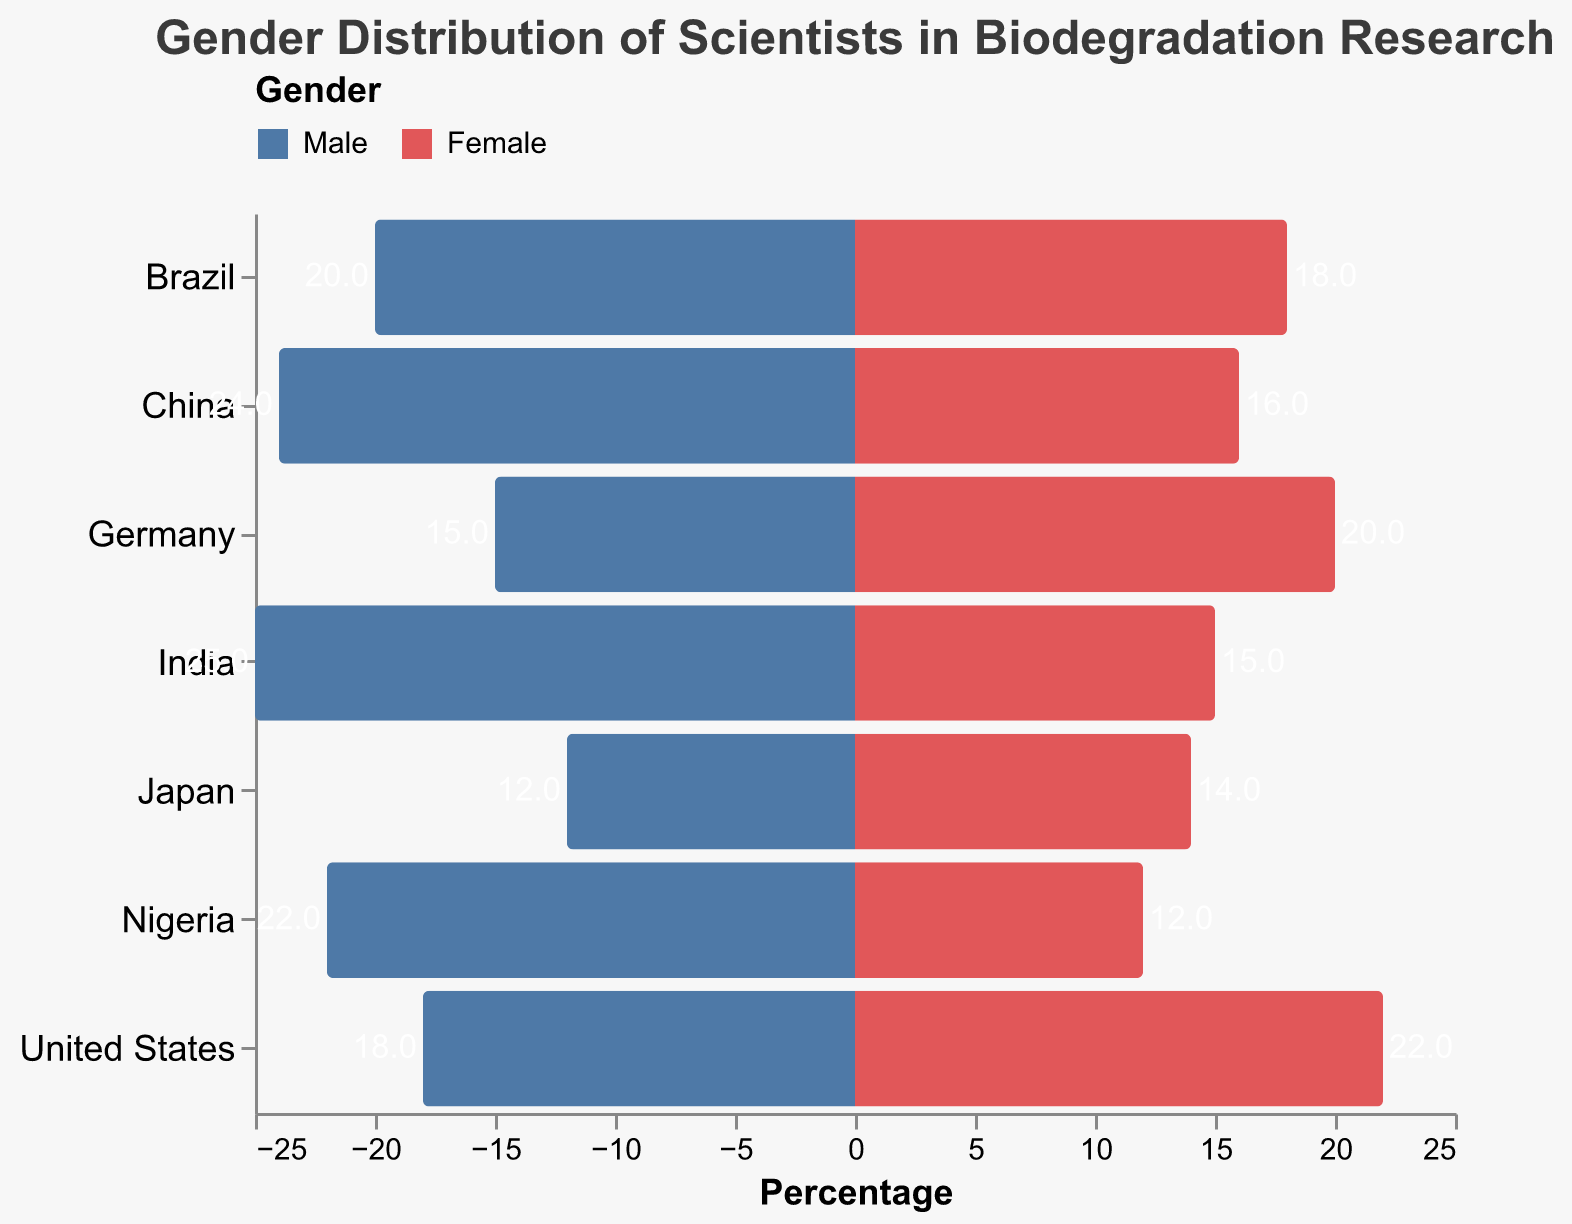What is the title of the figure? The title is displayed at the top of the figure and often summarizes the main topic.
Answer: Gender Distribution of Scientists in Biodegradation Research What is the percentage of female scientists in Germany? Locate Germany on the y-axis, and then check the bar corresponding to the female scientists (marked in red). The tooltip shows 20%.
Answer: 20% How many countries are represented in the pyramid plot? Count the distinct country labels listed on the y-axis.
Answer: 6 Which developed country has the highest percentage of female scientists? Compare the lengths of the red bars for developed countries (United States, Germany, Japan). The United States has the longest bar at 22%.
Answer: United States Which developing country has more male scientists, India or China? Compare the lengths of the blue bars for India and China. India has a 25% bar, while China has a 24% bar.
Answer: India What is the combined percentage of male scientists in Nigeria and Brazil? Add the values of the male percentages for Nigeria (22%) and Brazil (20%).
Answer: 42% In which developed country is the gender gap the smallest? For each developed country, calculate the difference between the male and female percentages. The smallest difference is in Japan (14% - 12% = 2%).
Answer: Japan Which country has the largest percentage of male scientists overall? Look for the longest blue bar in the whole pyramid plot. India's male bar is the longest at 25%.
Answer: India Is the percentage of female scientists in developing countries generally higher or lower than in developed countries? Compare the general trend of red bars in developing countries (India, Brazil, Nigeria, China) with those in developed countries (United States, Germany, Japan). The red bars in developing countries are generally shorter.
Answer: Lower 